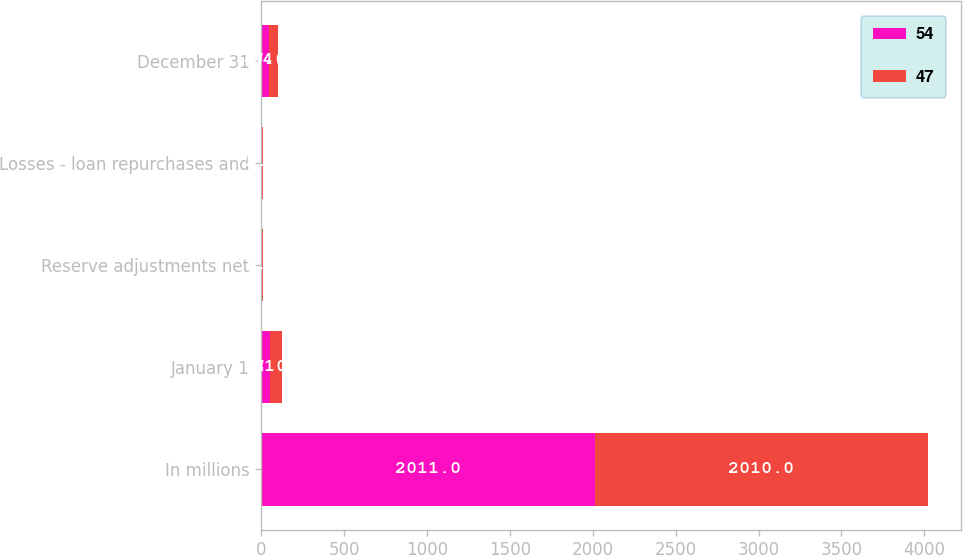Convert chart. <chart><loc_0><loc_0><loc_500><loc_500><stacked_bar_chart><ecel><fcel>In millions<fcel>January 1<fcel>Reserve adjustments net<fcel>Losses - loan repurchases and<fcel>December 31<nl><fcel>54<fcel>2011<fcel>54<fcel>1<fcel>8<fcel>47<nl><fcel>47<fcel>2010<fcel>71<fcel>9<fcel>2<fcel>54<nl></chart> 